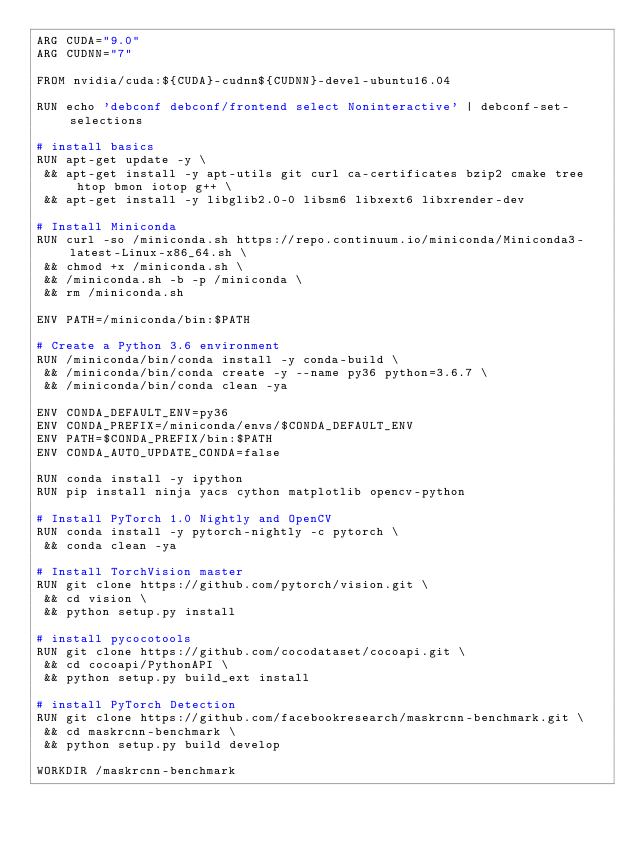<code> <loc_0><loc_0><loc_500><loc_500><_Dockerfile_>ARG CUDA="9.0"
ARG CUDNN="7"

FROM nvidia/cuda:${CUDA}-cudnn${CUDNN}-devel-ubuntu16.04

RUN echo 'debconf debconf/frontend select Noninteractive' | debconf-set-selections

# install basics
RUN apt-get update -y \
 && apt-get install -y apt-utils git curl ca-certificates bzip2 cmake tree htop bmon iotop g++ \
 && apt-get install -y libglib2.0-0 libsm6 libxext6 libxrender-dev

# Install Miniconda
RUN curl -so /miniconda.sh https://repo.continuum.io/miniconda/Miniconda3-latest-Linux-x86_64.sh \
 && chmod +x /miniconda.sh \
 && /miniconda.sh -b -p /miniconda \
 && rm /miniconda.sh

ENV PATH=/miniconda/bin:$PATH

# Create a Python 3.6 environment
RUN /miniconda/bin/conda install -y conda-build \
 && /miniconda/bin/conda create -y --name py36 python=3.6.7 \
 && /miniconda/bin/conda clean -ya

ENV CONDA_DEFAULT_ENV=py36
ENV CONDA_PREFIX=/miniconda/envs/$CONDA_DEFAULT_ENV
ENV PATH=$CONDA_PREFIX/bin:$PATH
ENV CONDA_AUTO_UPDATE_CONDA=false

RUN conda install -y ipython
RUN pip install ninja yacs cython matplotlib opencv-python

# Install PyTorch 1.0 Nightly and OpenCV
RUN conda install -y pytorch-nightly -c pytorch \
 && conda clean -ya

# Install TorchVision master
RUN git clone https://github.com/pytorch/vision.git \
 && cd vision \
 && python setup.py install

# install pycocotools
RUN git clone https://github.com/cocodataset/cocoapi.git \
 && cd cocoapi/PythonAPI \
 && python setup.py build_ext install

# install PyTorch Detection
RUN git clone https://github.com/facebookresearch/maskrcnn-benchmark.git \
 && cd maskrcnn-benchmark \
 && python setup.py build develop

WORKDIR /maskrcnn-benchmark
</code> 